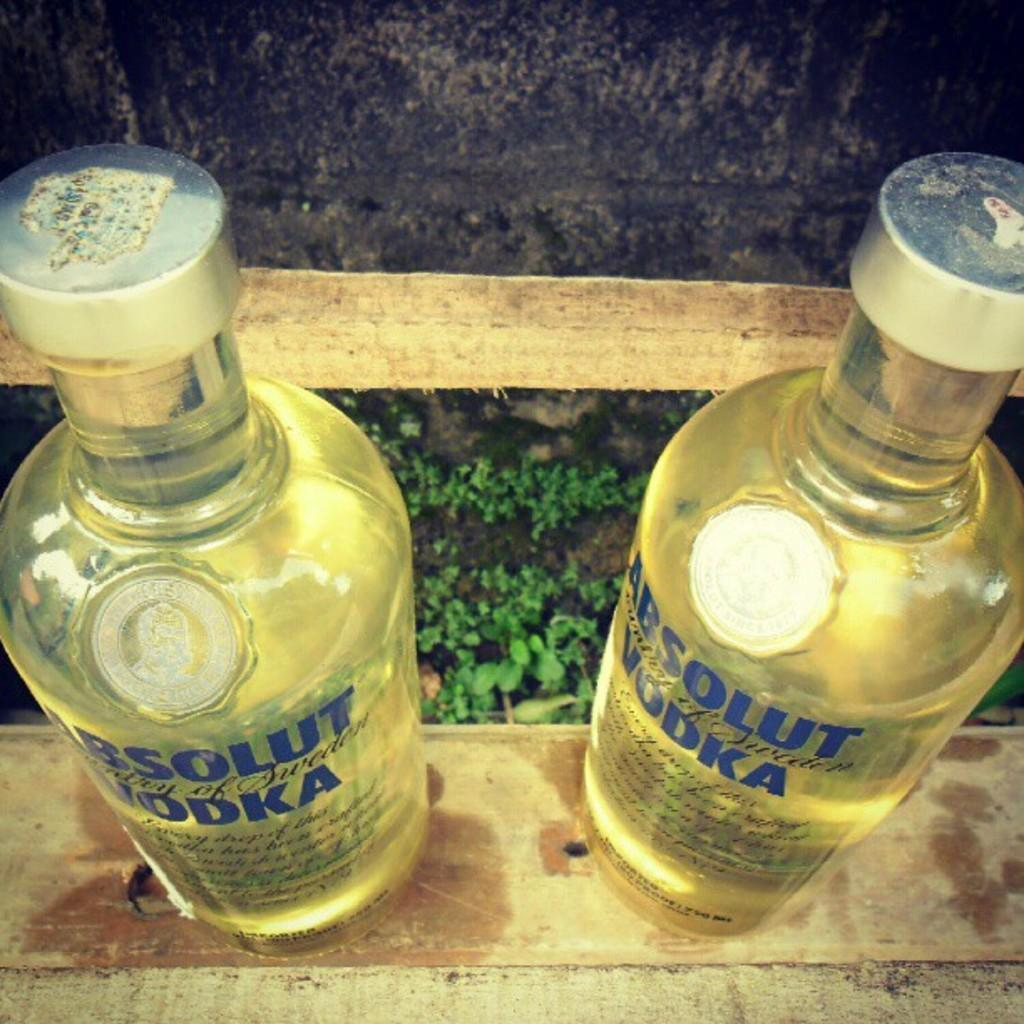<image>
Provide a brief description of the given image. Two full bottles of Absolut Vodka standing on a wooden surface 